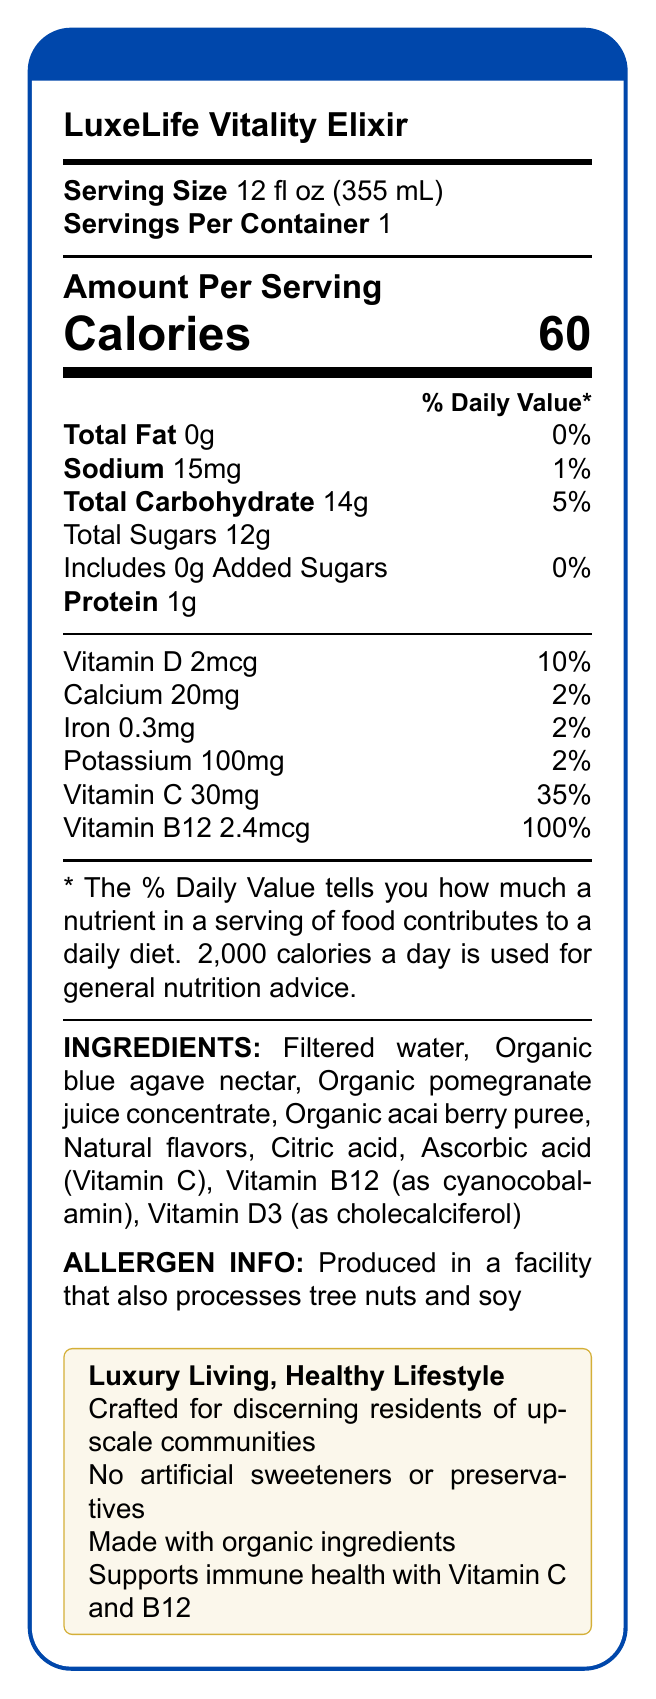what is the serving size of LuxeLife Vitality Elixir? The document lists the serving size for LuxeLife Vitality Elixir as 12 fl oz (355 mL).
Answer: 12 fl oz (355 mL) how much Vitamin B12 does one serving of LuxeLife Vitality Elixir contain? The document states that each serving provides 2.4mcg of Vitamin B12.
Answer: 2.4mcg what is the total amount of sugars in one serving of LuxeLife Vitality Elixir? According to the nutrition facts, there are 12g of total sugars per serving.
Answer: 12g Which vitamins are present in LuxeLife Vitality Elixir? The document lists Vitamin D, Vitamin C, and Vitamin B12 as part of the nutrition facts.
Answer: Vitamin D, Vitamin C, Vitamin B12 how much protein is in one serving? The document indicates that one serving contains 1g of protein.
Answer: 1g does LuxeLife Vitality Elixir contain any added sugars? The document specifies that there are 0g of added sugars in the beverage.
Answer: No what is the allergen information for LuxeLife Vitality Elixir? The allergen information section indicates that the product is made in a facility that processes tree nuts and soy.
Answer: Produced in a facility that also processes tree nuts and soy how many calories does one serving provide? The number of calories per serving is listed as 60 in the nutrition facts.
Answer: 60 how much sodium is in one serving? The nutrition facts list sodium content as 15mg per serving.
Answer: 15mg how is the LuxeLife Vitality Elixir described in the marketing claims? The document includes the marketing claims, highlighting its quality and health benefits.
Answer: Crafted for discerning residents of luxury communities, Formulated to support overall wellness and vitality, No artificial sweeteners or preservatives, Made with organic ingredients, Supports immune health with Vitamin C and B12 how does LuxeLife Vitality Elixir support immune health? The document states that the elixir supports immune health with Vitamin C and B12.
Answer: With Vitamin C and B12 What is the daily value percentage of Vitamin C in one serving? The document lists 35% as the daily value percentage for Vitamin C per serving.
Answer: 35% what type of individuals is LuxeLife Vitality Elixir marketed towards? The target audience is described as health-conscious individuals in upscale residential areas.
Answer: Health-conscious individuals in upscale residential areas which of the following is not a vitamin listed on the nutrition label of LuxeLife Vitality Elixir? A. Vitamin A B. Vitamin C C. Vitamin B12 D. Vitamin D The document lists Vitamins C, B12, and D but does not mention Vitamin A.
Answer: A. Vitamin A how many servings are there in one container of LuxeLife Vitality Elixir? A. 1 B. 2 C. 3 D. 4 The document specifies that there is 1 serving per container.
Answer: A. 1 Is LuxeLife Vitality Elixir made with artificial sweeteners? The document clearly states that there are no artificial sweeteners or preservatives.
Answer: No Summarize the main details provided in the LuxeLife Vitality Elixir nutrition facts and marketing claims. This summary covers the main points about the serving size, nutritional content, vitamins, marketing claims, target audience, and allergen information based on the document.
Answer: LuxeLife Vitality Elixir offers a detailed nutrition label for its health-focused beverage, highlighting a 12 fl oz serving size with 60 calories, 0g total fat, 15mg sodium, 14g total carbohydrates, 12g sugars, 1g protein, and various vitamins including D, C, and B12. The elixir is crafted with organic ingredients and is advertised to support overall wellness and vitality, without artificial sweeteners or preservatives. It's targeted towards health-conscious individuals in upscale residential communities. The allergen information indicates it is produced in a facility processing tree nuts and soy. how much potassium is in one serving of LuxeLife Vitality Elixir? The document lists 100mg of potassium per serving.
Answer: 100mg what is the shelf life of LuxeLife Vitality Elixir? The document does not provide information regarding the shelf life of the beverage.
Answer: I don't know 